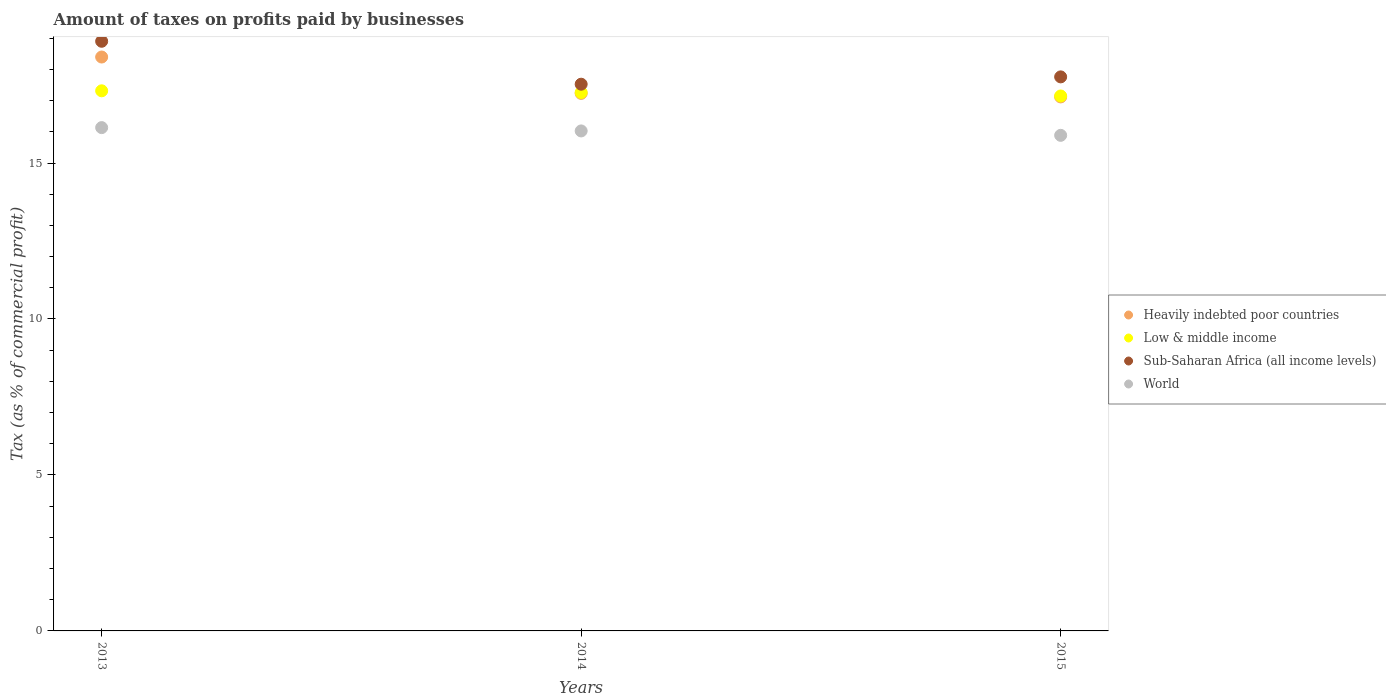What is the percentage of taxes paid by businesses in Heavily indebted poor countries in 2013?
Keep it short and to the point. 18.4. Across all years, what is the maximum percentage of taxes paid by businesses in Low & middle income?
Provide a short and direct response. 17.31. Across all years, what is the minimum percentage of taxes paid by businesses in Low & middle income?
Provide a short and direct response. 17.15. In which year was the percentage of taxes paid by businesses in World maximum?
Ensure brevity in your answer.  2013. In which year was the percentage of taxes paid by businesses in World minimum?
Your answer should be compact. 2015. What is the total percentage of taxes paid by businesses in World in the graph?
Your response must be concise. 48.05. What is the difference between the percentage of taxes paid by businesses in Sub-Saharan Africa (all income levels) in 2014 and that in 2015?
Provide a short and direct response. -0.23. What is the difference between the percentage of taxes paid by businesses in Low & middle income in 2013 and the percentage of taxes paid by businesses in Sub-Saharan Africa (all income levels) in 2014?
Ensure brevity in your answer.  -0.21. What is the average percentage of taxes paid by businesses in Low & middle income per year?
Your answer should be compact. 17.24. In the year 2015, what is the difference between the percentage of taxes paid by businesses in Low & middle income and percentage of taxes paid by businesses in Heavily indebted poor countries?
Ensure brevity in your answer.  0.03. In how many years, is the percentage of taxes paid by businesses in Heavily indebted poor countries greater than 18 %?
Offer a very short reply. 1. What is the ratio of the percentage of taxes paid by businesses in World in 2013 to that in 2015?
Ensure brevity in your answer.  1.02. Is the percentage of taxes paid by businesses in World in 2013 less than that in 2015?
Offer a very short reply. No. Is the difference between the percentage of taxes paid by businesses in Low & middle income in 2014 and 2015 greater than the difference between the percentage of taxes paid by businesses in Heavily indebted poor countries in 2014 and 2015?
Your answer should be very brief. No. What is the difference between the highest and the second highest percentage of taxes paid by businesses in Low & middle income?
Offer a very short reply. 0.05. What is the difference between the highest and the lowest percentage of taxes paid by businesses in Sub-Saharan Africa (all income levels)?
Give a very brief answer. 1.38. Is it the case that in every year, the sum of the percentage of taxes paid by businesses in World and percentage of taxes paid by businesses in Heavily indebted poor countries  is greater than the percentage of taxes paid by businesses in Sub-Saharan Africa (all income levels)?
Keep it short and to the point. Yes. Does the percentage of taxes paid by businesses in Sub-Saharan Africa (all income levels) monotonically increase over the years?
Offer a terse response. No. Is the percentage of taxes paid by businesses in Heavily indebted poor countries strictly greater than the percentage of taxes paid by businesses in Sub-Saharan Africa (all income levels) over the years?
Ensure brevity in your answer.  No. Is the percentage of taxes paid by businesses in Heavily indebted poor countries strictly less than the percentage of taxes paid by businesses in Low & middle income over the years?
Provide a succinct answer. No. Are the values on the major ticks of Y-axis written in scientific E-notation?
Your answer should be compact. No. Does the graph contain grids?
Make the answer very short. No. Where does the legend appear in the graph?
Offer a very short reply. Center right. How many legend labels are there?
Provide a succinct answer. 4. What is the title of the graph?
Keep it short and to the point. Amount of taxes on profits paid by businesses. What is the label or title of the Y-axis?
Keep it short and to the point. Tax (as % of commercial profit). What is the Tax (as % of commercial profit) in Heavily indebted poor countries in 2013?
Your answer should be compact. 18.4. What is the Tax (as % of commercial profit) in Low & middle income in 2013?
Keep it short and to the point. 17.31. What is the Tax (as % of commercial profit) in Sub-Saharan Africa (all income levels) in 2013?
Give a very brief answer. 18.9. What is the Tax (as % of commercial profit) in World in 2013?
Offer a very short reply. 16.13. What is the Tax (as % of commercial profit) of Heavily indebted poor countries in 2014?
Keep it short and to the point. 17.23. What is the Tax (as % of commercial profit) of Low & middle income in 2014?
Your answer should be compact. 17.26. What is the Tax (as % of commercial profit) in Sub-Saharan Africa (all income levels) in 2014?
Keep it short and to the point. 17.53. What is the Tax (as % of commercial profit) of World in 2014?
Keep it short and to the point. 16.03. What is the Tax (as % of commercial profit) in Heavily indebted poor countries in 2015?
Your answer should be compact. 17.12. What is the Tax (as % of commercial profit) in Low & middle income in 2015?
Offer a very short reply. 17.15. What is the Tax (as % of commercial profit) of Sub-Saharan Africa (all income levels) in 2015?
Ensure brevity in your answer.  17.76. What is the Tax (as % of commercial profit) of World in 2015?
Provide a succinct answer. 15.89. Across all years, what is the maximum Tax (as % of commercial profit) of Heavily indebted poor countries?
Keep it short and to the point. 18.4. Across all years, what is the maximum Tax (as % of commercial profit) in Low & middle income?
Offer a terse response. 17.31. Across all years, what is the maximum Tax (as % of commercial profit) of Sub-Saharan Africa (all income levels)?
Keep it short and to the point. 18.9. Across all years, what is the maximum Tax (as % of commercial profit) of World?
Your response must be concise. 16.13. Across all years, what is the minimum Tax (as % of commercial profit) of Heavily indebted poor countries?
Offer a very short reply. 17.12. Across all years, what is the minimum Tax (as % of commercial profit) of Low & middle income?
Make the answer very short. 17.15. Across all years, what is the minimum Tax (as % of commercial profit) of Sub-Saharan Africa (all income levels)?
Ensure brevity in your answer.  17.53. Across all years, what is the minimum Tax (as % of commercial profit) in World?
Your response must be concise. 15.89. What is the total Tax (as % of commercial profit) of Heavily indebted poor countries in the graph?
Keep it short and to the point. 52.75. What is the total Tax (as % of commercial profit) of Low & middle income in the graph?
Your answer should be compact. 51.72. What is the total Tax (as % of commercial profit) in Sub-Saharan Africa (all income levels) in the graph?
Provide a succinct answer. 54.19. What is the total Tax (as % of commercial profit) in World in the graph?
Ensure brevity in your answer.  48.05. What is the difference between the Tax (as % of commercial profit) in Heavily indebted poor countries in 2013 and that in 2014?
Your answer should be very brief. 1.17. What is the difference between the Tax (as % of commercial profit) in Low & middle income in 2013 and that in 2014?
Your answer should be compact. 0.05. What is the difference between the Tax (as % of commercial profit) of Sub-Saharan Africa (all income levels) in 2013 and that in 2014?
Make the answer very short. 1.38. What is the difference between the Tax (as % of commercial profit) in World in 2013 and that in 2014?
Ensure brevity in your answer.  0.11. What is the difference between the Tax (as % of commercial profit) in Heavily indebted poor countries in 2013 and that in 2015?
Keep it short and to the point. 1.28. What is the difference between the Tax (as % of commercial profit) of Low & middle income in 2013 and that in 2015?
Offer a very short reply. 0.17. What is the difference between the Tax (as % of commercial profit) of Sub-Saharan Africa (all income levels) in 2013 and that in 2015?
Offer a terse response. 1.14. What is the difference between the Tax (as % of commercial profit) in World in 2013 and that in 2015?
Keep it short and to the point. 0.25. What is the difference between the Tax (as % of commercial profit) of Heavily indebted poor countries in 2014 and that in 2015?
Your answer should be very brief. 0.11. What is the difference between the Tax (as % of commercial profit) in Low & middle income in 2014 and that in 2015?
Keep it short and to the point. 0.11. What is the difference between the Tax (as % of commercial profit) in Sub-Saharan Africa (all income levels) in 2014 and that in 2015?
Provide a short and direct response. -0.23. What is the difference between the Tax (as % of commercial profit) in World in 2014 and that in 2015?
Offer a terse response. 0.14. What is the difference between the Tax (as % of commercial profit) of Heavily indebted poor countries in 2013 and the Tax (as % of commercial profit) of Low & middle income in 2014?
Ensure brevity in your answer.  1.14. What is the difference between the Tax (as % of commercial profit) in Heavily indebted poor countries in 2013 and the Tax (as % of commercial profit) in Sub-Saharan Africa (all income levels) in 2014?
Provide a succinct answer. 0.87. What is the difference between the Tax (as % of commercial profit) of Heavily indebted poor countries in 2013 and the Tax (as % of commercial profit) of World in 2014?
Offer a terse response. 2.37. What is the difference between the Tax (as % of commercial profit) of Low & middle income in 2013 and the Tax (as % of commercial profit) of Sub-Saharan Africa (all income levels) in 2014?
Your response must be concise. -0.21. What is the difference between the Tax (as % of commercial profit) in Low & middle income in 2013 and the Tax (as % of commercial profit) in World in 2014?
Offer a terse response. 1.29. What is the difference between the Tax (as % of commercial profit) of Sub-Saharan Africa (all income levels) in 2013 and the Tax (as % of commercial profit) of World in 2014?
Your answer should be compact. 2.87. What is the difference between the Tax (as % of commercial profit) of Heavily indebted poor countries in 2013 and the Tax (as % of commercial profit) of Low & middle income in 2015?
Offer a terse response. 1.25. What is the difference between the Tax (as % of commercial profit) of Heavily indebted poor countries in 2013 and the Tax (as % of commercial profit) of Sub-Saharan Africa (all income levels) in 2015?
Make the answer very short. 0.64. What is the difference between the Tax (as % of commercial profit) in Heavily indebted poor countries in 2013 and the Tax (as % of commercial profit) in World in 2015?
Provide a short and direct response. 2.51. What is the difference between the Tax (as % of commercial profit) in Low & middle income in 2013 and the Tax (as % of commercial profit) in Sub-Saharan Africa (all income levels) in 2015?
Offer a very short reply. -0.45. What is the difference between the Tax (as % of commercial profit) in Low & middle income in 2013 and the Tax (as % of commercial profit) in World in 2015?
Ensure brevity in your answer.  1.43. What is the difference between the Tax (as % of commercial profit) in Sub-Saharan Africa (all income levels) in 2013 and the Tax (as % of commercial profit) in World in 2015?
Keep it short and to the point. 3.02. What is the difference between the Tax (as % of commercial profit) in Heavily indebted poor countries in 2014 and the Tax (as % of commercial profit) in Low & middle income in 2015?
Your answer should be compact. 0.08. What is the difference between the Tax (as % of commercial profit) in Heavily indebted poor countries in 2014 and the Tax (as % of commercial profit) in Sub-Saharan Africa (all income levels) in 2015?
Your answer should be compact. -0.53. What is the difference between the Tax (as % of commercial profit) of Heavily indebted poor countries in 2014 and the Tax (as % of commercial profit) of World in 2015?
Your answer should be compact. 1.34. What is the difference between the Tax (as % of commercial profit) in Low & middle income in 2014 and the Tax (as % of commercial profit) in Sub-Saharan Africa (all income levels) in 2015?
Your response must be concise. -0.5. What is the difference between the Tax (as % of commercial profit) of Low & middle income in 2014 and the Tax (as % of commercial profit) of World in 2015?
Offer a terse response. 1.37. What is the difference between the Tax (as % of commercial profit) in Sub-Saharan Africa (all income levels) in 2014 and the Tax (as % of commercial profit) in World in 2015?
Your answer should be very brief. 1.64. What is the average Tax (as % of commercial profit) in Heavily indebted poor countries per year?
Keep it short and to the point. 17.58. What is the average Tax (as % of commercial profit) of Low & middle income per year?
Offer a terse response. 17.24. What is the average Tax (as % of commercial profit) of Sub-Saharan Africa (all income levels) per year?
Your response must be concise. 18.06. What is the average Tax (as % of commercial profit) of World per year?
Provide a short and direct response. 16.02. In the year 2013, what is the difference between the Tax (as % of commercial profit) in Heavily indebted poor countries and Tax (as % of commercial profit) in Low & middle income?
Give a very brief answer. 1.08. In the year 2013, what is the difference between the Tax (as % of commercial profit) in Heavily indebted poor countries and Tax (as % of commercial profit) in Sub-Saharan Africa (all income levels)?
Offer a very short reply. -0.5. In the year 2013, what is the difference between the Tax (as % of commercial profit) in Heavily indebted poor countries and Tax (as % of commercial profit) in World?
Your answer should be very brief. 2.26. In the year 2013, what is the difference between the Tax (as % of commercial profit) of Low & middle income and Tax (as % of commercial profit) of Sub-Saharan Africa (all income levels)?
Give a very brief answer. -1.59. In the year 2013, what is the difference between the Tax (as % of commercial profit) in Low & middle income and Tax (as % of commercial profit) in World?
Keep it short and to the point. 1.18. In the year 2013, what is the difference between the Tax (as % of commercial profit) of Sub-Saharan Africa (all income levels) and Tax (as % of commercial profit) of World?
Ensure brevity in your answer.  2.77. In the year 2014, what is the difference between the Tax (as % of commercial profit) of Heavily indebted poor countries and Tax (as % of commercial profit) of Low & middle income?
Give a very brief answer. -0.03. In the year 2014, what is the difference between the Tax (as % of commercial profit) of Heavily indebted poor countries and Tax (as % of commercial profit) of Sub-Saharan Africa (all income levels)?
Your answer should be compact. -0.29. In the year 2014, what is the difference between the Tax (as % of commercial profit) in Heavily indebted poor countries and Tax (as % of commercial profit) in World?
Ensure brevity in your answer.  1.2. In the year 2014, what is the difference between the Tax (as % of commercial profit) of Low & middle income and Tax (as % of commercial profit) of Sub-Saharan Africa (all income levels)?
Provide a short and direct response. -0.27. In the year 2014, what is the difference between the Tax (as % of commercial profit) in Low & middle income and Tax (as % of commercial profit) in World?
Provide a succinct answer. 1.23. In the year 2014, what is the difference between the Tax (as % of commercial profit) in Sub-Saharan Africa (all income levels) and Tax (as % of commercial profit) in World?
Your response must be concise. 1.5. In the year 2015, what is the difference between the Tax (as % of commercial profit) of Heavily indebted poor countries and Tax (as % of commercial profit) of Low & middle income?
Give a very brief answer. -0.03. In the year 2015, what is the difference between the Tax (as % of commercial profit) in Heavily indebted poor countries and Tax (as % of commercial profit) in Sub-Saharan Africa (all income levels)?
Offer a very short reply. -0.64. In the year 2015, what is the difference between the Tax (as % of commercial profit) of Heavily indebted poor countries and Tax (as % of commercial profit) of World?
Keep it short and to the point. 1.23. In the year 2015, what is the difference between the Tax (as % of commercial profit) in Low & middle income and Tax (as % of commercial profit) in Sub-Saharan Africa (all income levels)?
Provide a short and direct response. -0.61. In the year 2015, what is the difference between the Tax (as % of commercial profit) of Low & middle income and Tax (as % of commercial profit) of World?
Ensure brevity in your answer.  1.26. In the year 2015, what is the difference between the Tax (as % of commercial profit) in Sub-Saharan Africa (all income levels) and Tax (as % of commercial profit) in World?
Ensure brevity in your answer.  1.87. What is the ratio of the Tax (as % of commercial profit) of Heavily indebted poor countries in 2013 to that in 2014?
Keep it short and to the point. 1.07. What is the ratio of the Tax (as % of commercial profit) in Sub-Saharan Africa (all income levels) in 2013 to that in 2014?
Offer a terse response. 1.08. What is the ratio of the Tax (as % of commercial profit) of World in 2013 to that in 2014?
Keep it short and to the point. 1.01. What is the ratio of the Tax (as % of commercial profit) of Heavily indebted poor countries in 2013 to that in 2015?
Your answer should be very brief. 1.07. What is the ratio of the Tax (as % of commercial profit) in Low & middle income in 2013 to that in 2015?
Give a very brief answer. 1.01. What is the ratio of the Tax (as % of commercial profit) of Sub-Saharan Africa (all income levels) in 2013 to that in 2015?
Provide a succinct answer. 1.06. What is the ratio of the Tax (as % of commercial profit) in World in 2013 to that in 2015?
Your response must be concise. 1.02. What is the ratio of the Tax (as % of commercial profit) of Heavily indebted poor countries in 2014 to that in 2015?
Your response must be concise. 1.01. What is the ratio of the Tax (as % of commercial profit) of Low & middle income in 2014 to that in 2015?
Keep it short and to the point. 1.01. What is the ratio of the Tax (as % of commercial profit) in World in 2014 to that in 2015?
Ensure brevity in your answer.  1.01. What is the difference between the highest and the second highest Tax (as % of commercial profit) in Heavily indebted poor countries?
Offer a very short reply. 1.17. What is the difference between the highest and the second highest Tax (as % of commercial profit) of Low & middle income?
Your response must be concise. 0.05. What is the difference between the highest and the second highest Tax (as % of commercial profit) in Sub-Saharan Africa (all income levels)?
Ensure brevity in your answer.  1.14. What is the difference between the highest and the second highest Tax (as % of commercial profit) of World?
Give a very brief answer. 0.11. What is the difference between the highest and the lowest Tax (as % of commercial profit) of Heavily indebted poor countries?
Your response must be concise. 1.28. What is the difference between the highest and the lowest Tax (as % of commercial profit) of Low & middle income?
Keep it short and to the point. 0.17. What is the difference between the highest and the lowest Tax (as % of commercial profit) of Sub-Saharan Africa (all income levels)?
Provide a short and direct response. 1.38. What is the difference between the highest and the lowest Tax (as % of commercial profit) of World?
Offer a very short reply. 0.25. 